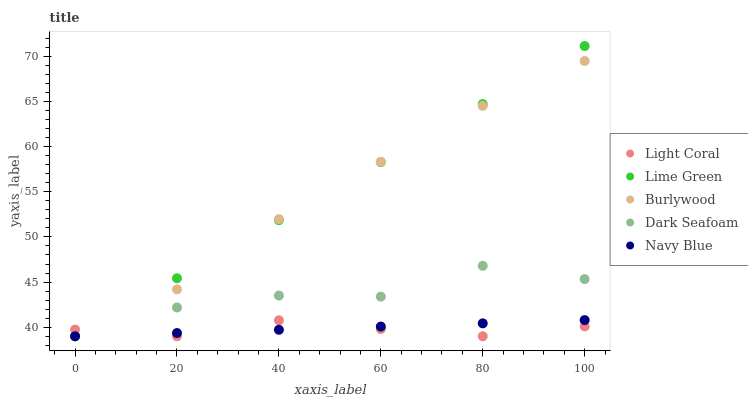Does Light Coral have the minimum area under the curve?
Answer yes or no. Yes. Does Lime Green have the maximum area under the curve?
Answer yes or no. Yes. Does Burlywood have the minimum area under the curve?
Answer yes or no. No. Does Burlywood have the maximum area under the curve?
Answer yes or no. No. Is Lime Green the smoothest?
Answer yes or no. Yes. Is Dark Seafoam the roughest?
Answer yes or no. Yes. Is Burlywood the smoothest?
Answer yes or no. No. Is Burlywood the roughest?
Answer yes or no. No. Does Light Coral have the lowest value?
Answer yes or no. Yes. Does Lime Green have the highest value?
Answer yes or no. Yes. Does Burlywood have the highest value?
Answer yes or no. No. Does Burlywood intersect Lime Green?
Answer yes or no. Yes. Is Burlywood less than Lime Green?
Answer yes or no. No. Is Burlywood greater than Lime Green?
Answer yes or no. No. 